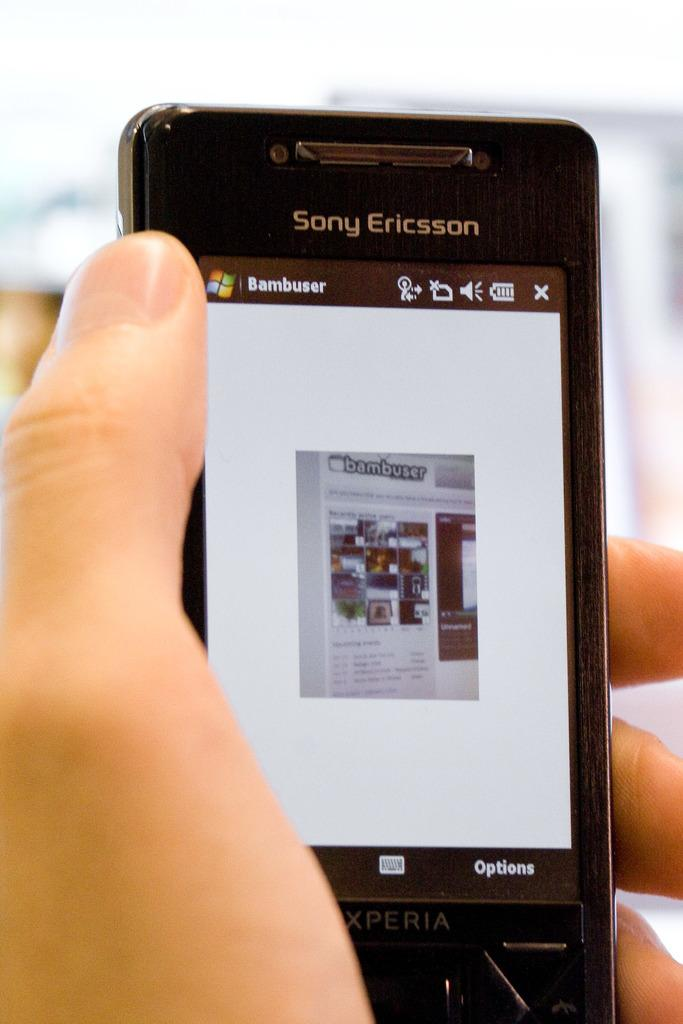<image>
Share a concise interpretation of the image provided. a phone that has the words sony ericsson on it 